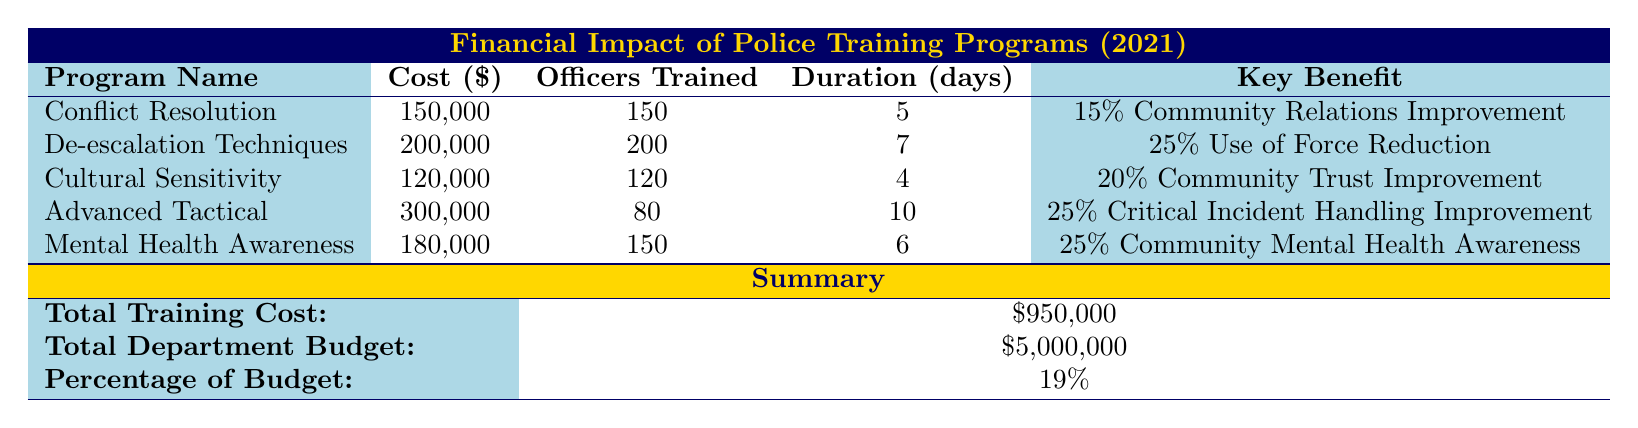What is the total cost for all training programs? The total cost for all training programs is provided in the summary section of the table. It states that the total training cost sums up to 950,000 dollars.
Answer: 950,000 How many officers were trained through the De-escalation Techniques program? The number of officers trained is explicitly mentioned in the table under the De-escalation Techniques section, which shows that 200 officers participated in this program.
Answer: 200 Did the Advanced Tactical Training program have the highest cost among all training programs? To determine this, we can compare the costs listed for each program. The Advanced Tactical Training program's cost is 300,000 dollars, which is higher than all other programs listed.
Answer: Yes What percentage of the total budget did the training programs account for? The percentage of the total budget allocated for training programs is provided in the summary section. It indicates that training programs accounted for 19 percent of the total budget.
Answer: 19 percent What is the average cost per officer trained for the Conflict Resolution Training program? The total cost for the Conflict Resolution Training program is 150,000 dollars, and it trained 150 officers. To find the average cost per officer, divide the total cost by the number of officers: 150,000 / 150 = 1,000.
Answer: 1,000 Which training program showed the highest potential reduction in use of force? The table specifies that the De-escalation Techniques program has a potential reduction in use of force of 25 percent, more than any other program.
Answer: De-escalation Techniques What was the duration of the Cultural Sensitivity Training? The duration for the Cultural Sensitivity Training program is listed directly in the table as 4 days.
Answer: 4 days Which program aimed to improve community mental health awareness? The table indicates that the Mental Health Awareness Training program is specifically designed to improve community mental health awareness, showing a 25 percent improvement in that area.
Answer: Mental Health Awareness Training How many officers were trained in total across all programs? To find the total number of officers trained, we add the number of officers trained in each program: 150 (Conflict Resolution) + 200 (De-escalation) + 120 (Cultural Sensitivity) + 80 (Advanced Tactical) + 150 (Mental Health Awareness) = 800.
Answer: 800 